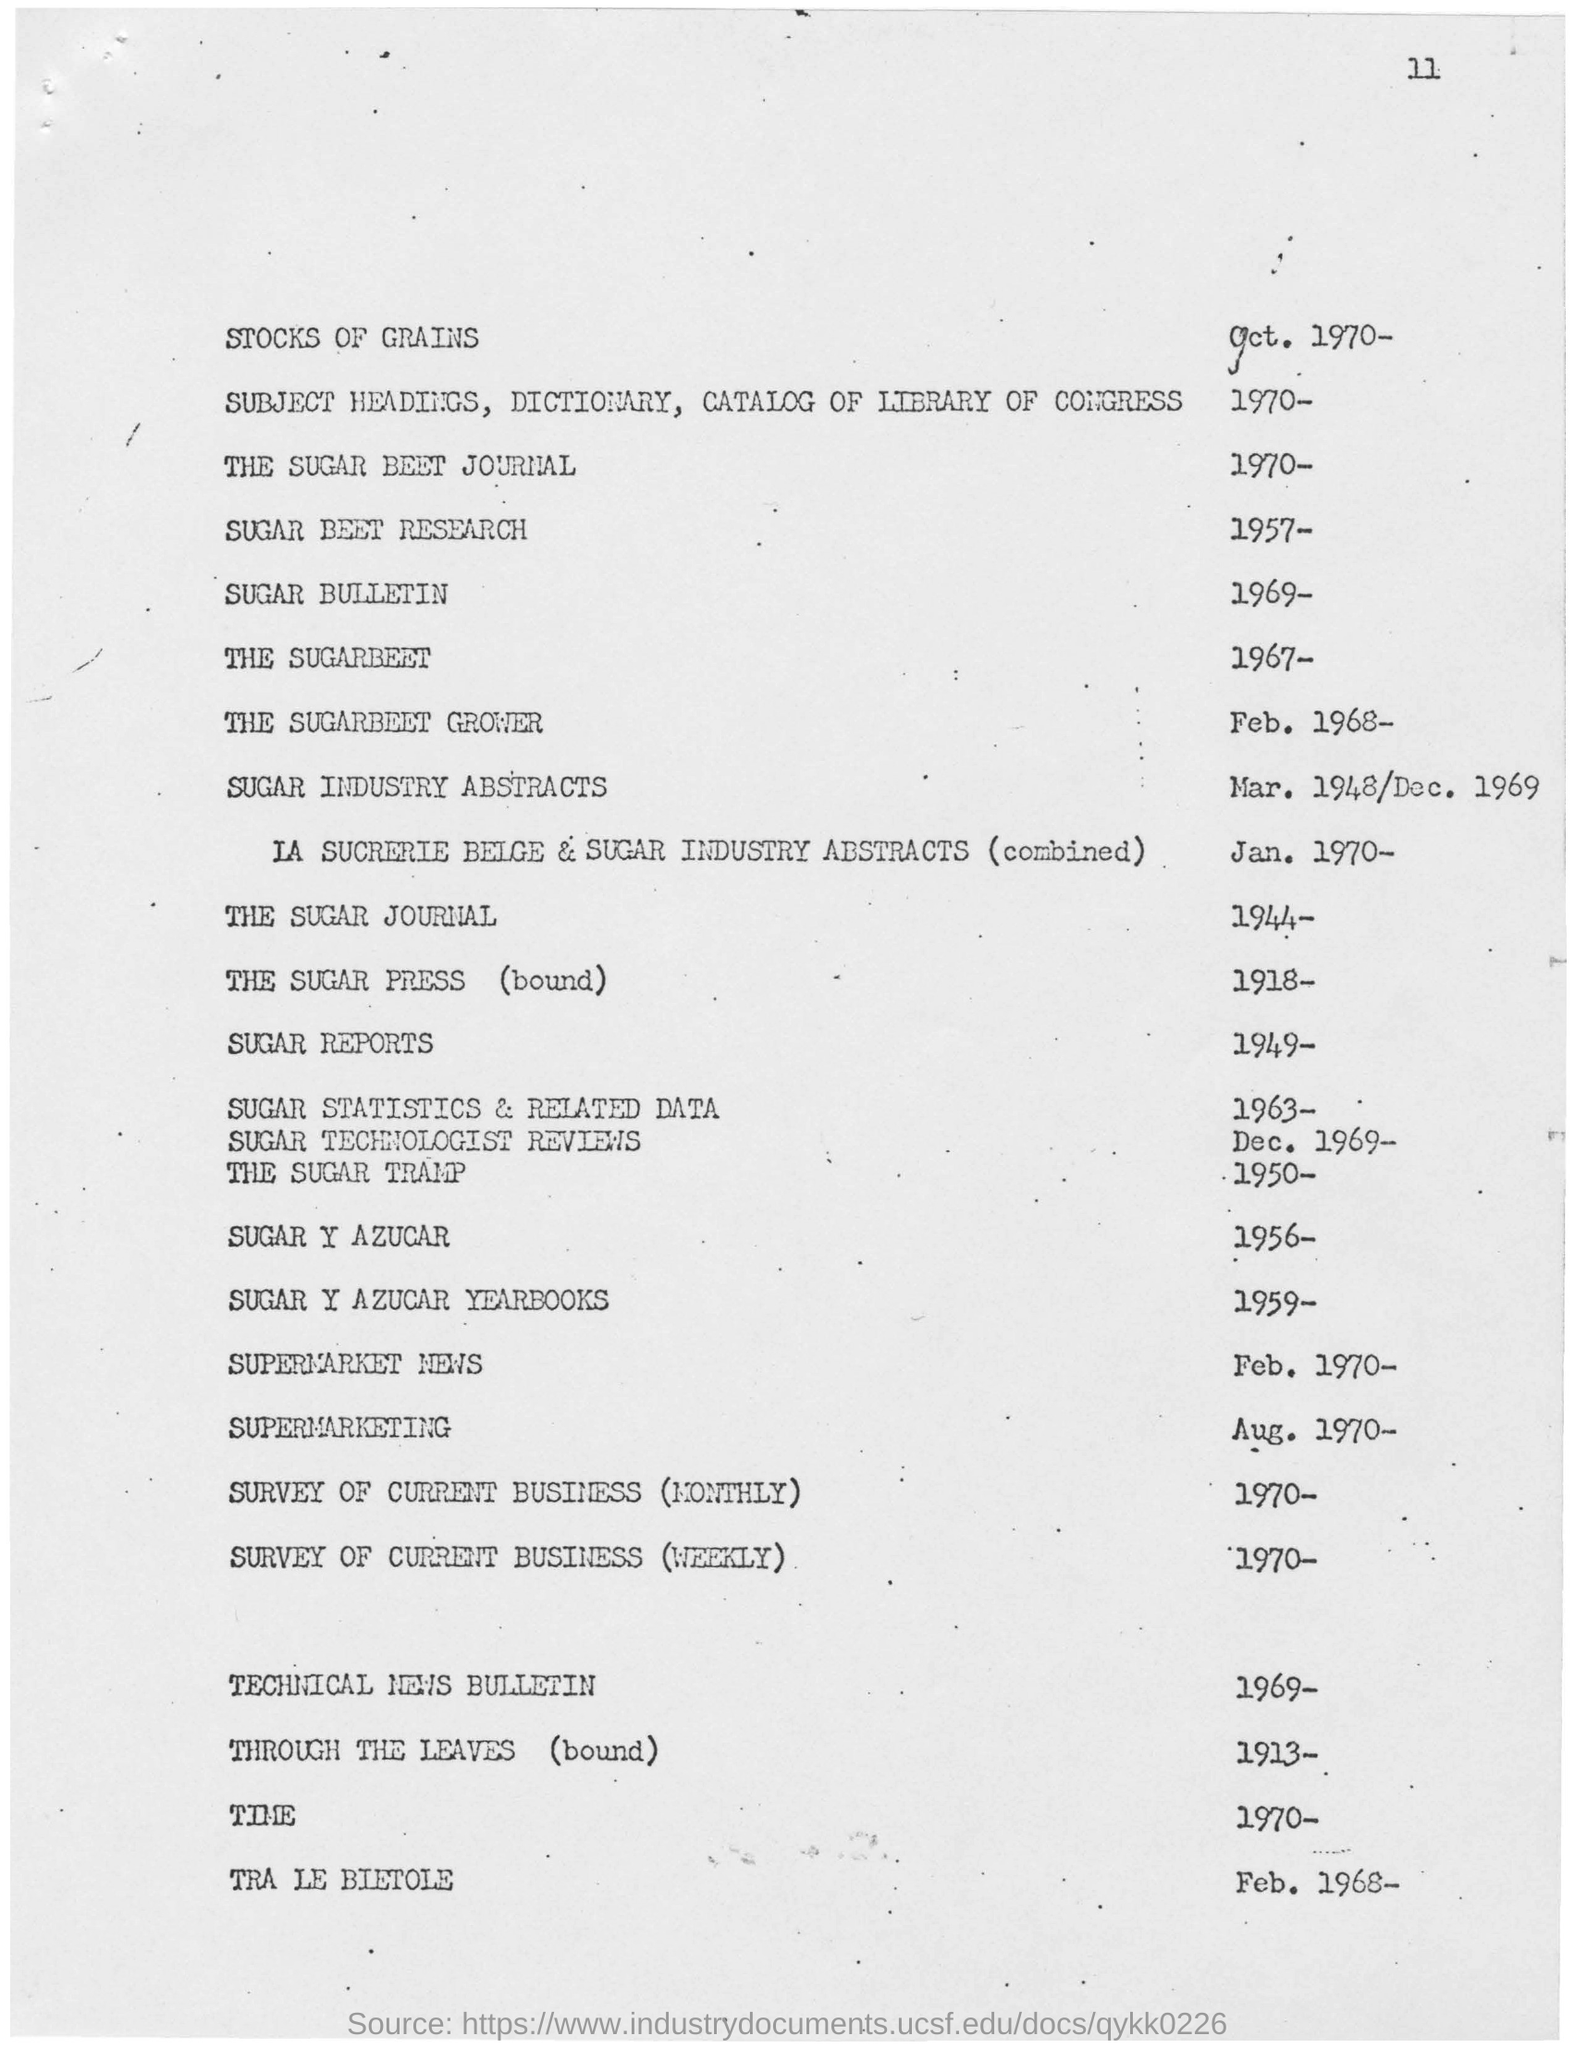What is the year mentioned for sugar beet research?
Ensure brevity in your answer.  1957-. What is the year mentioned for the sugar beet grower ?
Give a very brief answer. 1968-. What is the year mentioned for the sugar beet journal ?
Your response must be concise. 1970. 